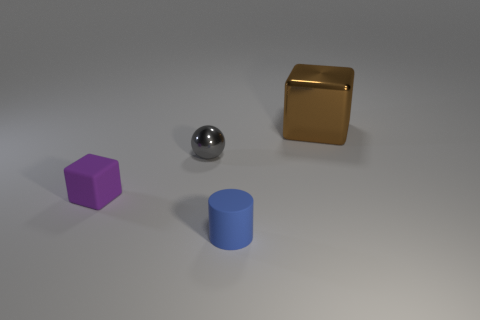Add 2 big brown shiny cubes. How many objects exist? 6 Subtract all balls. How many objects are left? 3 Subtract 0 green balls. How many objects are left? 4 Subtract all large cyan rubber cubes. Subtract all small objects. How many objects are left? 1 Add 2 tiny gray metallic objects. How many tiny gray metallic objects are left? 3 Add 3 small green matte spheres. How many small green matte spheres exist? 3 